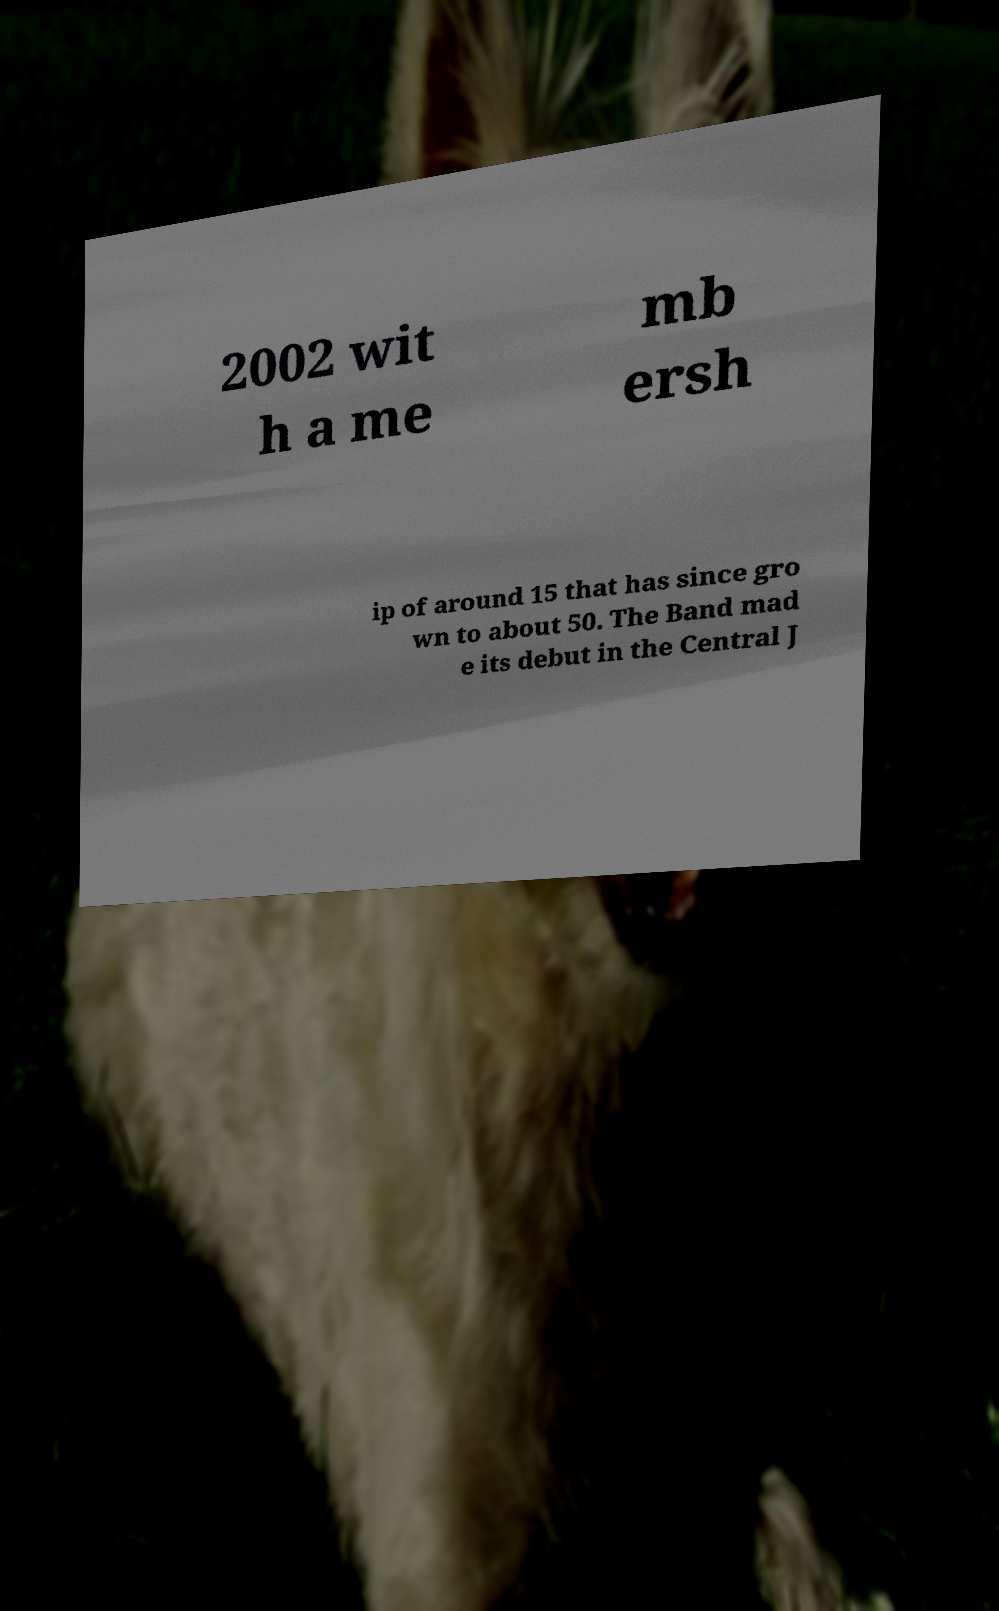There's text embedded in this image that I need extracted. Can you transcribe it verbatim? 2002 wit h a me mb ersh ip of around 15 that has since gro wn to about 50. The Band mad e its debut in the Central J 